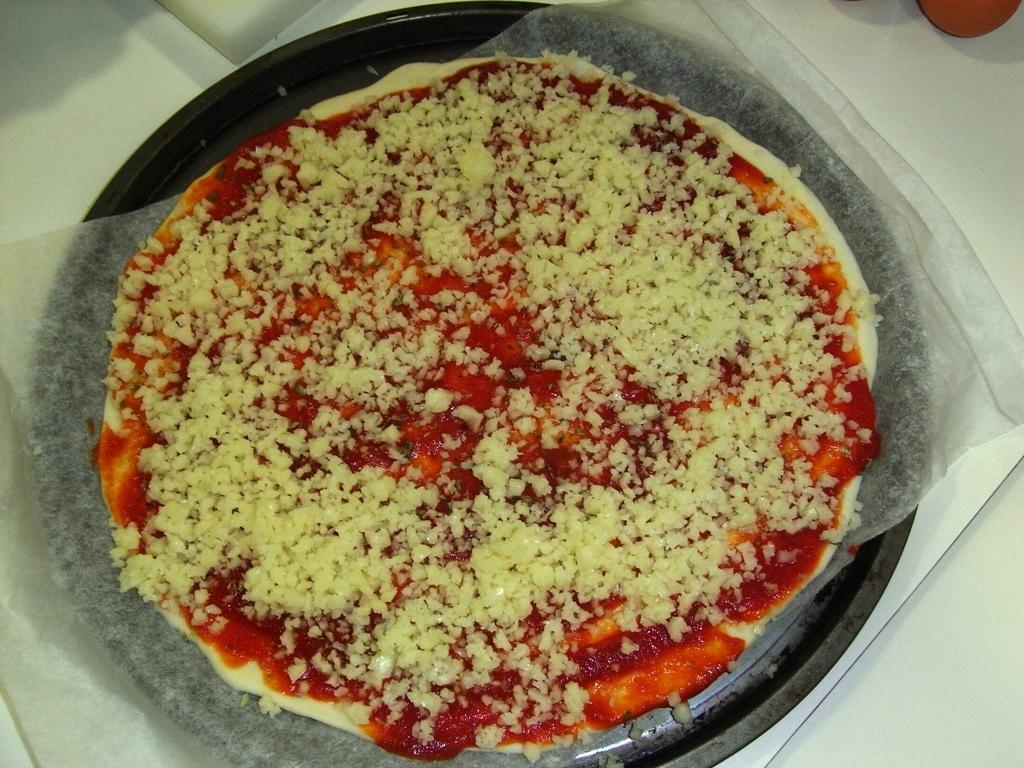Describe this image in one or two sentences. In this image I can see the food in the bowl. The food is in cream and red color, and the bowl is in black color. The bowl is on the white color surface. 